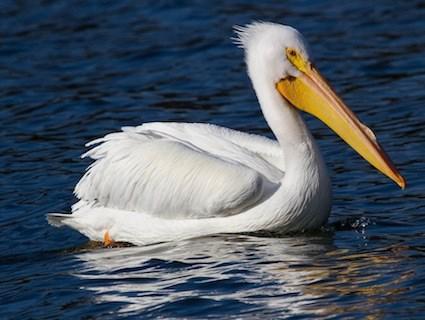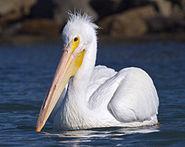The first image is the image on the left, the second image is the image on the right. For the images shown, is this caption "There is one bird flying in the picture on the right." true? Answer yes or no. No. 